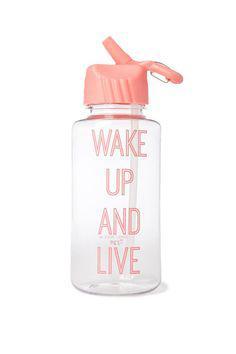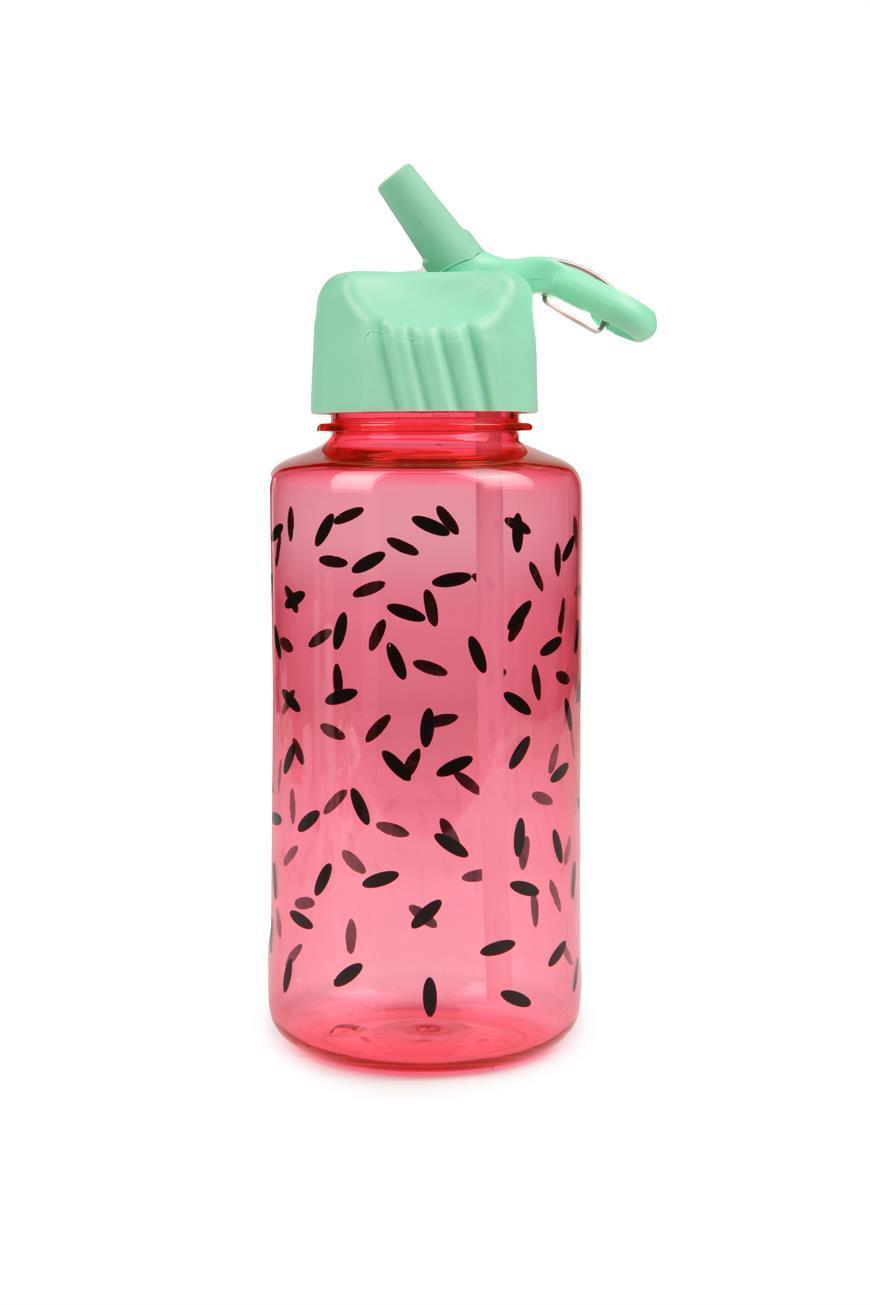The first image is the image on the left, the second image is the image on the right. For the images displayed, is the sentence "Each image shows a bottle shaped like a cylinder with straight sides, and the water bottle on the right is pink with a pattern of small black ovals and has a green cap with a loop on the right." factually correct? Answer yes or no. Yes. The first image is the image on the left, the second image is the image on the right. For the images displayed, is the sentence "Two water bottles both have matching caps, but are different colors and one bottle is much bigger." factually correct? Answer yes or no. No. 